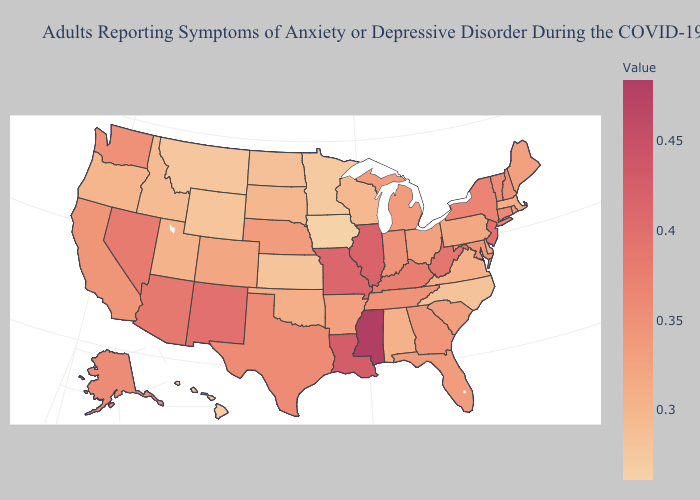Does Delaware have the lowest value in the South?
Quick response, please. No. Is the legend a continuous bar?
Write a very short answer. Yes. Among the states that border New Mexico , which have the highest value?
Give a very brief answer. Arizona. Does Maryland have a higher value than Missouri?
Keep it brief. No. 